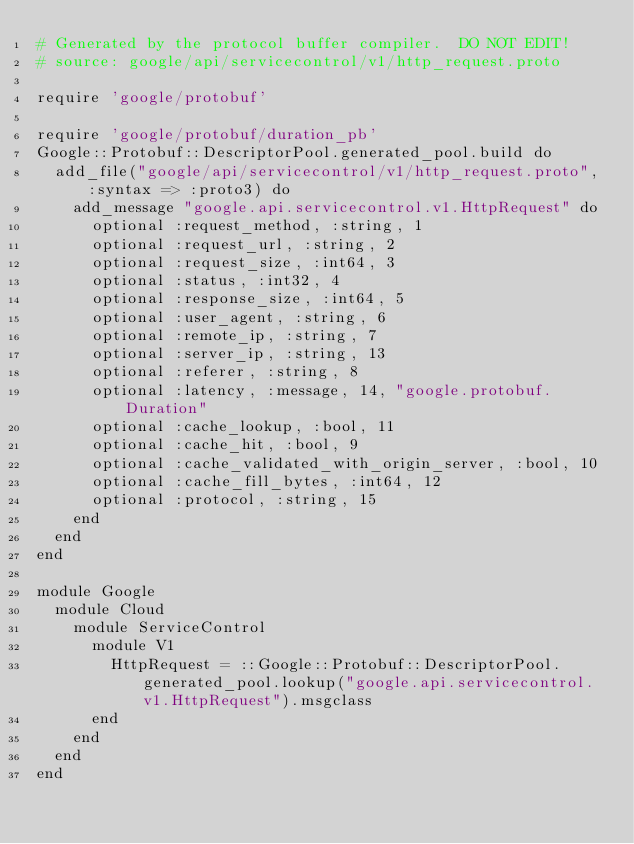Convert code to text. <code><loc_0><loc_0><loc_500><loc_500><_Ruby_># Generated by the protocol buffer compiler.  DO NOT EDIT!
# source: google/api/servicecontrol/v1/http_request.proto

require 'google/protobuf'

require 'google/protobuf/duration_pb'
Google::Protobuf::DescriptorPool.generated_pool.build do
  add_file("google/api/servicecontrol/v1/http_request.proto", :syntax => :proto3) do
    add_message "google.api.servicecontrol.v1.HttpRequest" do
      optional :request_method, :string, 1
      optional :request_url, :string, 2
      optional :request_size, :int64, 3
      optional :status, :int32, 4
      optional :response_size, :int64, 5
      optional :user_agent, :string, 6
      optional :remote_ip, :string, 7
      optional :server_ip, :string, 13
      optional :referer, :string, 8
      optional :latency, :message, 14, "google.protobuf.Duration"
      optional :cache_lookup, :bool, 11
      optional :cache_hit, :bool, 9
      optional :cache_validated_with_origin_server, :bool, 10
      optional :cache_fill_bytes, :int64, 12
      optional :protocol, :string, 15
    end
  end
end

module Google
  module Cloud
    module ServiceControl
      module V1
        HttpRequest = ::Google::Protobuf::DescriptorPool.generated_pool.lookup("google.api.servicecontrol.v1.HttpRequest").msgclass
      end
    end
  end
end
</code> 